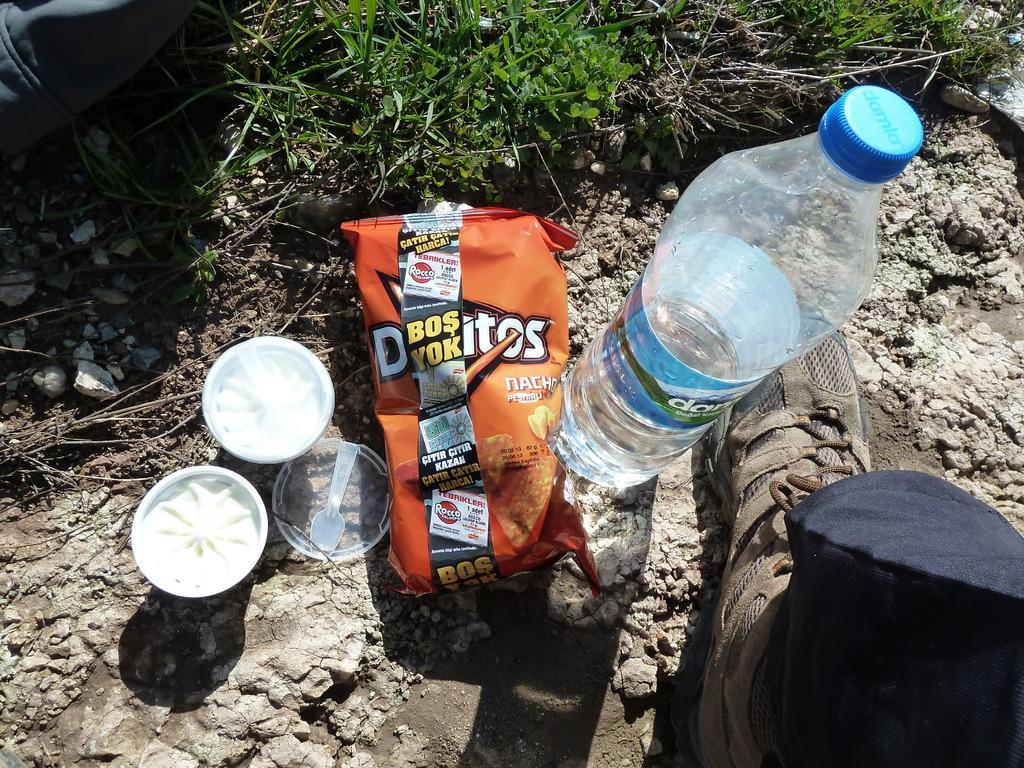What type of container is present in the image? There is a bottle in the image. What type of snack is visible in the image? There is a chips packet in the image. What is the third item that can be seen in the image? There is a bowl in the image. What utensil is present in the image? There is a spoon in the image. What type of footwear is on the floor in the image? There is a person's shoe on the floor in the image. What is the floor made of in the image? The floor appears to be made of rocks. What type of plant can be seen in the image? There is a tree visible in the image. What type of chain is being used to secure the toy in the image? There is no chain or toy present in the image. 